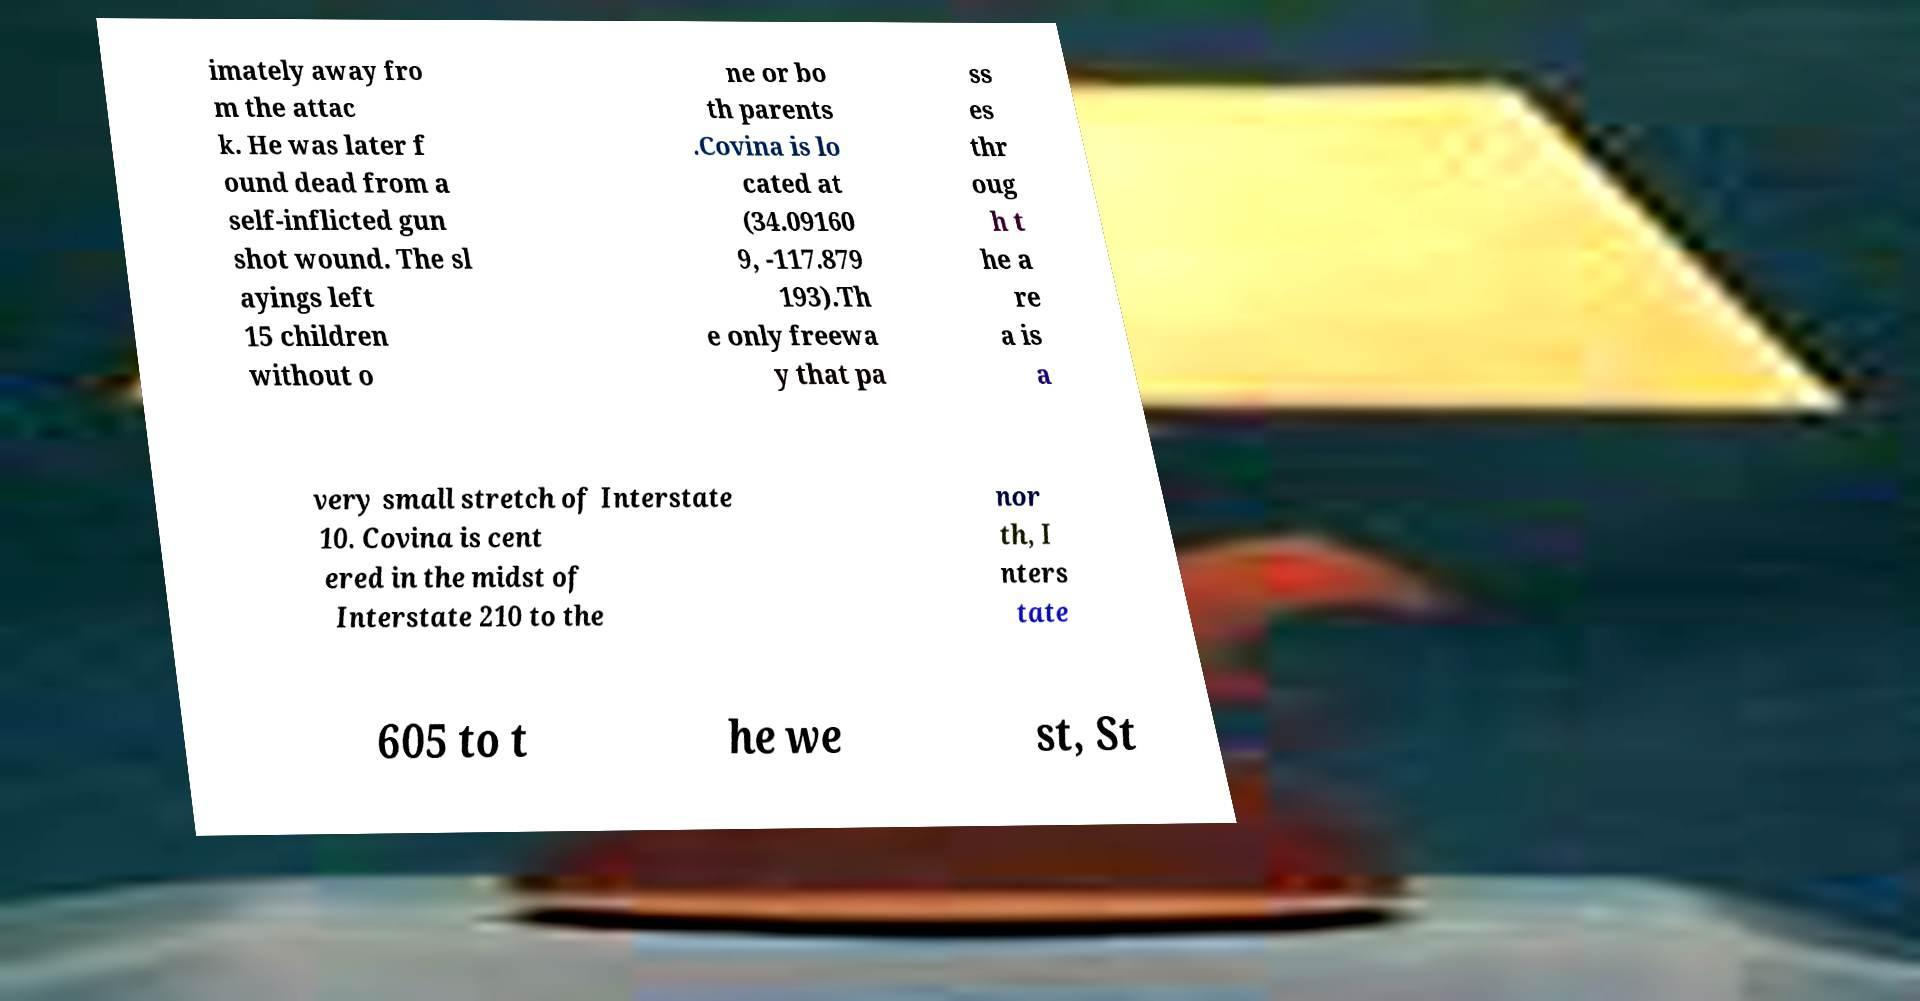Please identify and transcribe the text found in this image. imately away fro m the attac k. He was later f ound dead from a self-inflicted gun shot wound. The sl ayings left 15 children without o ne or bo th parents .Covina is lo cated at (34.09160 9, -117.879 193).Th e only freewa y that pa ss es thr oug h t he a re a is a very small stretch of Interstate 10. Covina is cent ered in the midst of Interstate 210 to the nor th, I nters tate 605 to t he we st, St 